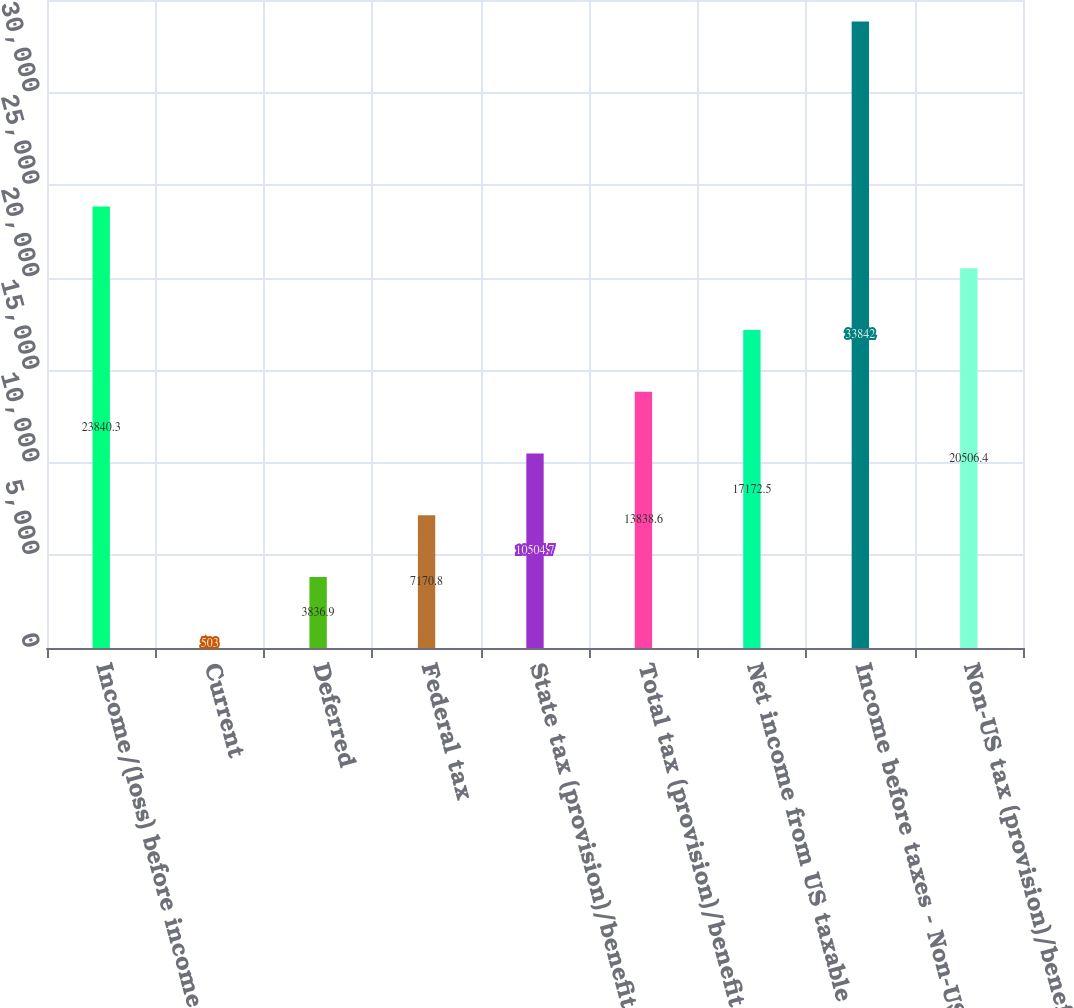<chart> <loc_0><loc_0><loc_500><loc_500><bar_chart><fcel>Income/(loss) before income<fcel>Current<fcel>Deferred<fcel>Federal tax<fcel>State tax (provision)/benefit<fcel>Total tax (provision)/benefit<fcel>Net income from US taxable<fcel>Income before taxes - Non-US<fcel>Non-US tax (provision)/benefit<nl><fcel>23840.3<fcel>503<fcel>3836.9<fcel>7170.8<fcel>10504.7<fcel>13838.6<fcel>17172.5<fcel>33842<fcel>20506.4<nl></chart> 